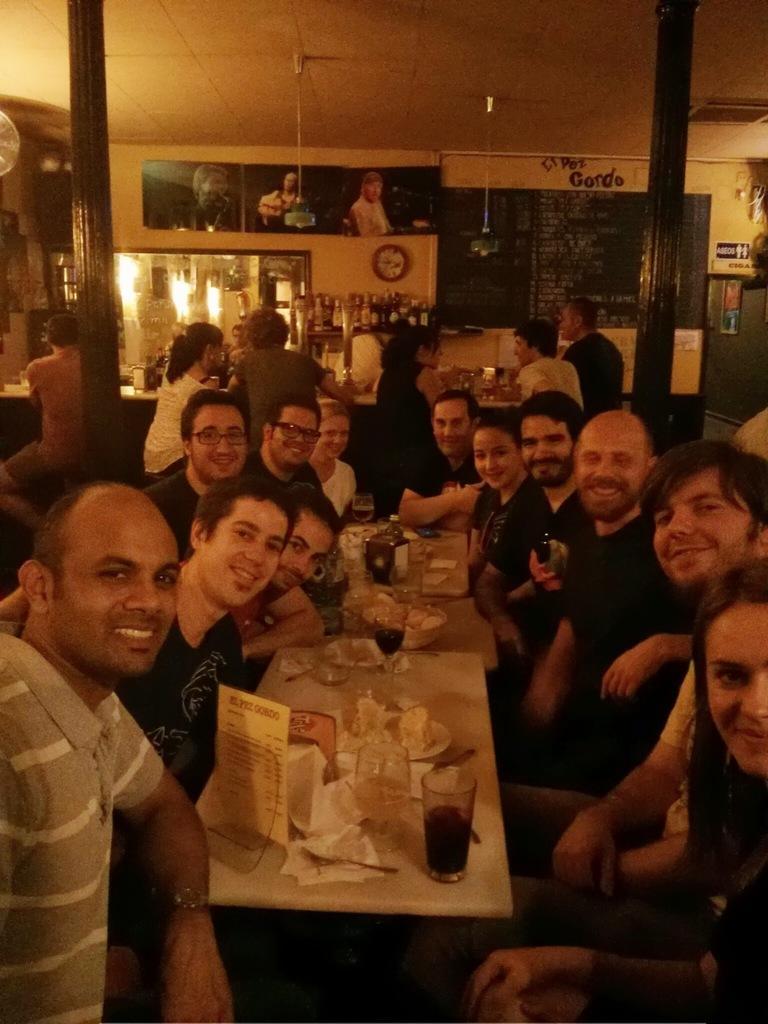Describe this image in one or two sentences. It is a restaurant , group of people are sitting around the table there is a lot of food and drinks on the table in the background it is a bar, there are some posters on the wall, a clock and also a menu card. 